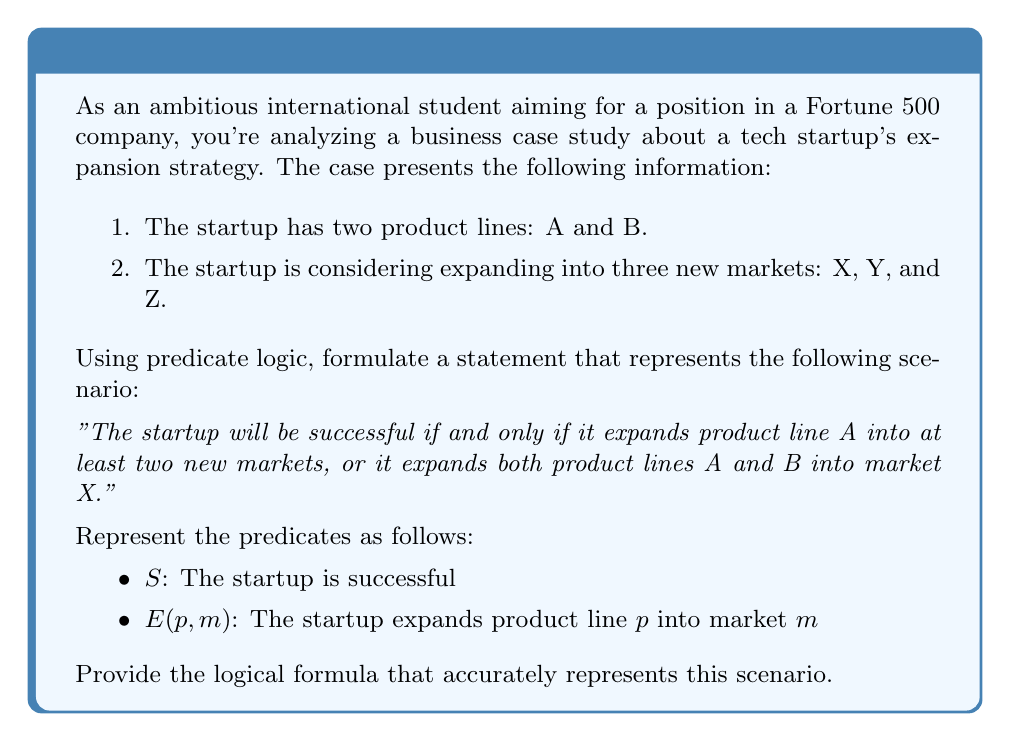Can you solve this math problem? Let's break this down step-by-step:

1. First, we need to represent "expanding product line A into at least two new markets." This can be written as:

   $$(E(A,X) \land E(A,Y)) \lor (E(A,X) \land E(A,Z)) \lor (E(A,Y) \land E(A,Z))$$

2. Next, we need to represent "expanding both product lines A and B into market X":

   $$E(A,X) \land E(B,X)$$

3. The scenario states that the startup will be successful if and only if either of these conditions is met. In logical terms, this is a biconditional statement. We can represent this as:

   $$S \iff ((E(A,X) \land E(A,Y)) \lor (E(A,X) \land E(A,Z)) \lor (E(A,Y) \land E(A,Z))) \lor (E(A,X) \land E(B,X))$$

4. This formula can be read as: "The startup is successful if and only if (product line A expands into at least two markets) or (both product lines A and B expand into market X)."

5. The biconditional operator $\iff$ ensures that the success of the startup is both necessary and sufficient for the conditions on the right side of the equation to be true.

This logical formula encapsulates the complex business scenario in a precise mathematical form, allowing for rigorous analysis of the startup's expansion strategy.
Answer: $$S \iff ((E(A,X) \land E(A,Y)) \lor (E(A,X) \land E(A,Z)) \lor (E(A,Y) \land E(A,Z))) \lor (E(A,X) \land E(B,X))$$ 